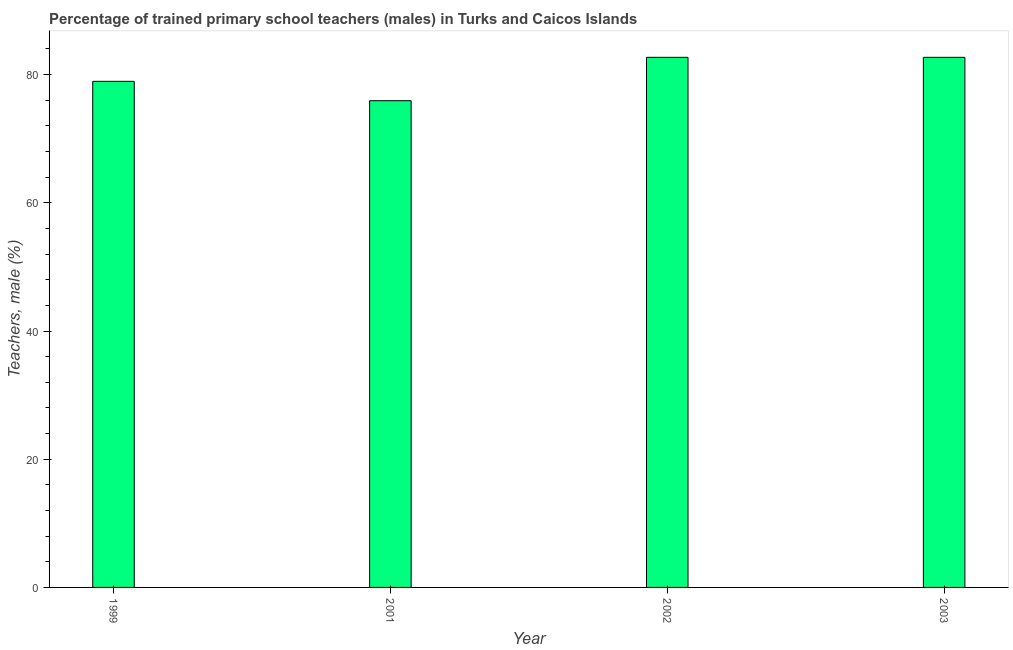Does the graph contain grids?
Offer a terse response. No. What is the title of the graph?
Offer a terse response. Percentage of trained primary school teachers (males) in Turks and Caicos Islands. What is the label or title of the Y-axis?
Make the answer very short. Teachers, male (%). What is the percentage of trained male teachers in 2003?
Make the answer very short. 82.69. Across all years, what is the maximum percentage of trained male teachers?
Keep it short and to the point. 82.69. Across all years, what is the minimum percentage of trained male teachers?
Keep it short and to the point. 75.93. In which year was the percentage of trained male teachers maximum?
Your response must be concise. 2002. What is the sum of the percentage of trained male teachers?
Make the answer very short. 320.26. What is the difference between the percentage of trained male teachers in 1999 and 2002?
Provide a short and direct response. -3.75. What is the average percentage of trained male teachers per year?
Your answer should be compact. 80.06. What is the median percentage of trained male teachers?
Provide a succinct answer. 80.82. Do a majority of the years between 1999 and 2003 (inclusive) have percentage of trained male teachers greater than 80 %?
Offer a very short reply. No. What is the ratio of the percentage of trained male teachers in 1999 to that in 2003?
Provide a succinct answer. 0.95. Is the percentage of trained male teachers in 1999 less than that in 2001?
Ensure brevity in your answer.  No. What is the difference between the highest and the second highest percentage of trained male teachers?
Keep it short and to the point. 0. What is the difference between the highest and the lowest percentage of trained male teachers?
Offer a terse response. 6.77. In how many years, is the percentage of trained male teachers greater than the average percentage of trained male teachers taken over all years?
Offer a terse response. 2. How many years are there in the graph?
Your answer should be compact. 4. Are the values on the major ticks of Y-axis written in scientific E-notation?
Your answer should be compact. No. What is the Teachers, male (%) of 1999?
Keep it short and to the point. 78.95. What is the Teachers, male (%) of 2001?
Offer a very short reply. 75.93. What is the Teachers, male (%) of 2002?
Offer a terse response. 82.69. What is the Teachers, male (%) in 2003?
Provide a succinct answer. 82.69. What is the difference between the Teachers, male (%) in 1999 and 2001?
Provide a short and direct response. 3.02. What is the difference between the Teachers, male (%) in 1999 and 2002?
Your answer should be compact. -3.74. What is the difference between the Teachers, male (%) in 1999 and 2003?
Your response must be concise. -3.74. What is the difference between the Teachers, male (%) in 2001 and 2002?
Make the answer very short. -6.77. What is the difference between the Teachers, male (%) in 2001 and 2003?
Offer a very short reply. -6.77. What is the ratio of the Teachers, male (%) in 1999 to that in 2001?
Provide a succinct answer. 1.04. What is the ratio of the Teachers, male (%) in 1999 to that in 2002?
Offer a terse response. 0.95. What is the ratio of the Teachers, male (%) in 1999 to that in 2003?
Offer a very short reply. 0.95. What is the ratio of the Teachers, male (%) in 2001 to that in 2002?
Keep it short and to the point. 0.92. What is the ratio of the Teachers, male (%) in 2001 to that in 2003?
Make the answer very short. 0.92. What is the ratio of the Teachers, male (%) in 2002 to that in 2003?
Keep it short and to the point. 1. 